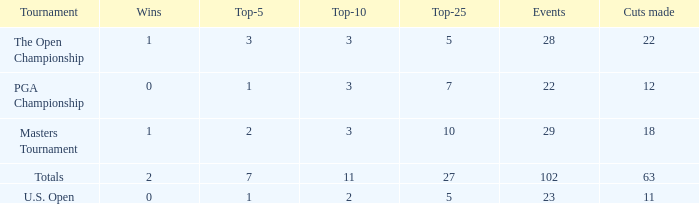How many top 10s associated with 3 top 5s and under 22 cuts made? None. 